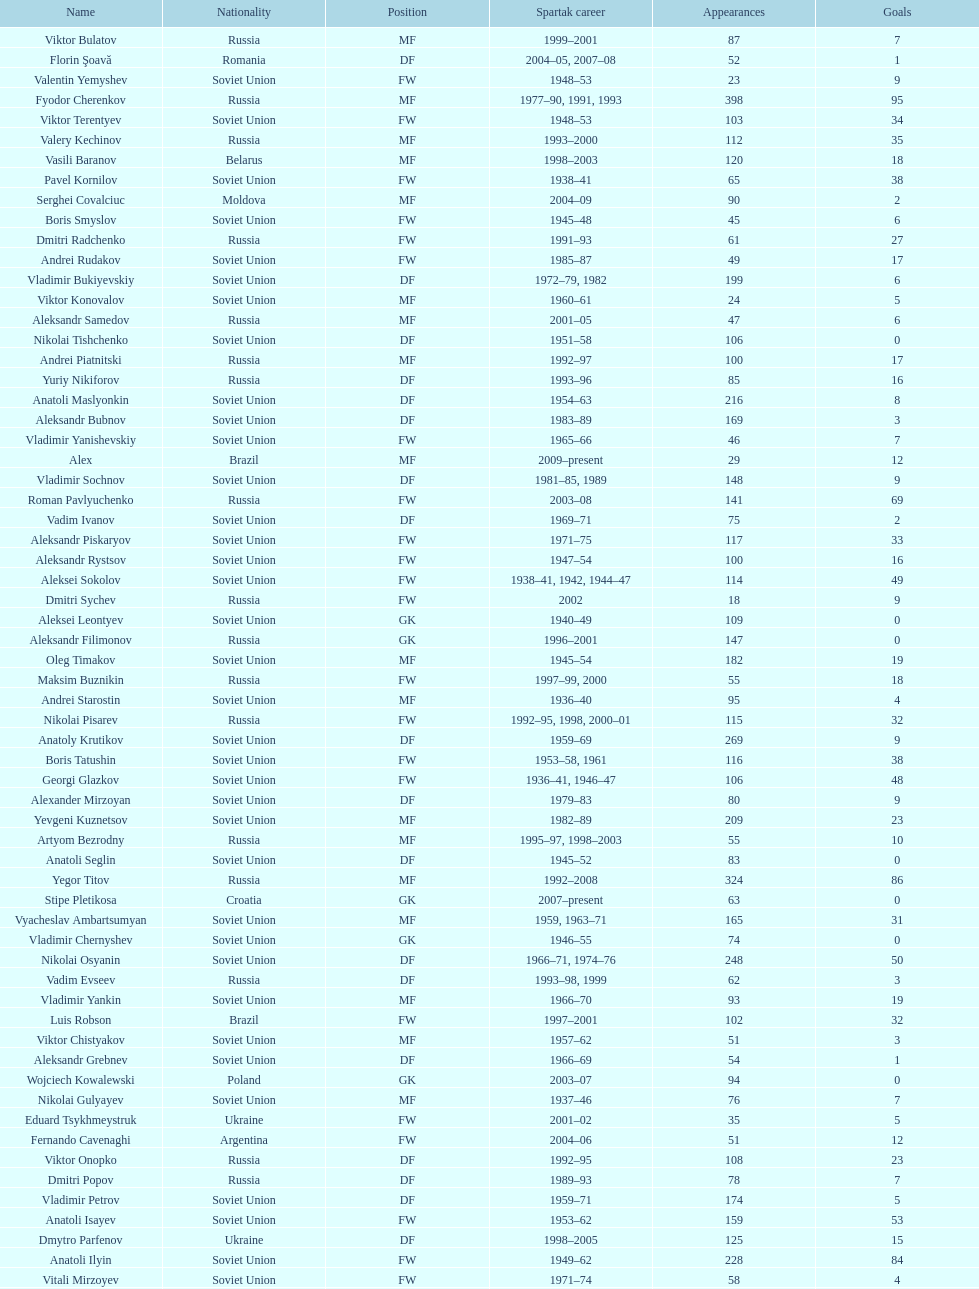Baranov has played from 2004 to the present. what is his nationality? Belarus. 